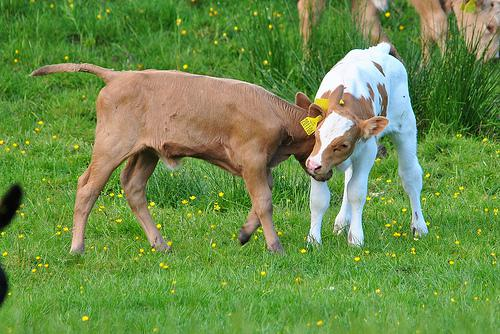Question: when was this taken?
Choices:
A. During the evening.
B. During the morning.
C. During the afternoon.
D. During the day.
Answer with the letter. Answer: D Question: how many animals are there?
Choices:
A. 1.
B. 3.
C. 2.
D. 5.
Answer with the letter. Answer: C Question: why are they head butting?
Choices:
A. Fighting.
B. Rough-housing.
C. Playing.
D. Disagreeing.
Answer with the letter. Answer: C Question: what color is the grass?
Choices:
A. Green.
B. Blue.
C. Red.
D. Brown.
Answer with the letter. Answer: A Question: what animal is this?
Choices:
A. Ram.
B. Goat.
C. Sheep.
D. Ewe.
Answer with the letter. Answer: B Question: where are they playing?
Choices:
A. In the meadow.
B. In the grassy field.
C. In the yard.
D. In the parking lot.
Answer with the letter. Answer: B Question: who is sitting down?
Choices:
A. Everyone.
B. Some people.
C. Half the people.
D. No one.
Answer with the letter. Answer: D 